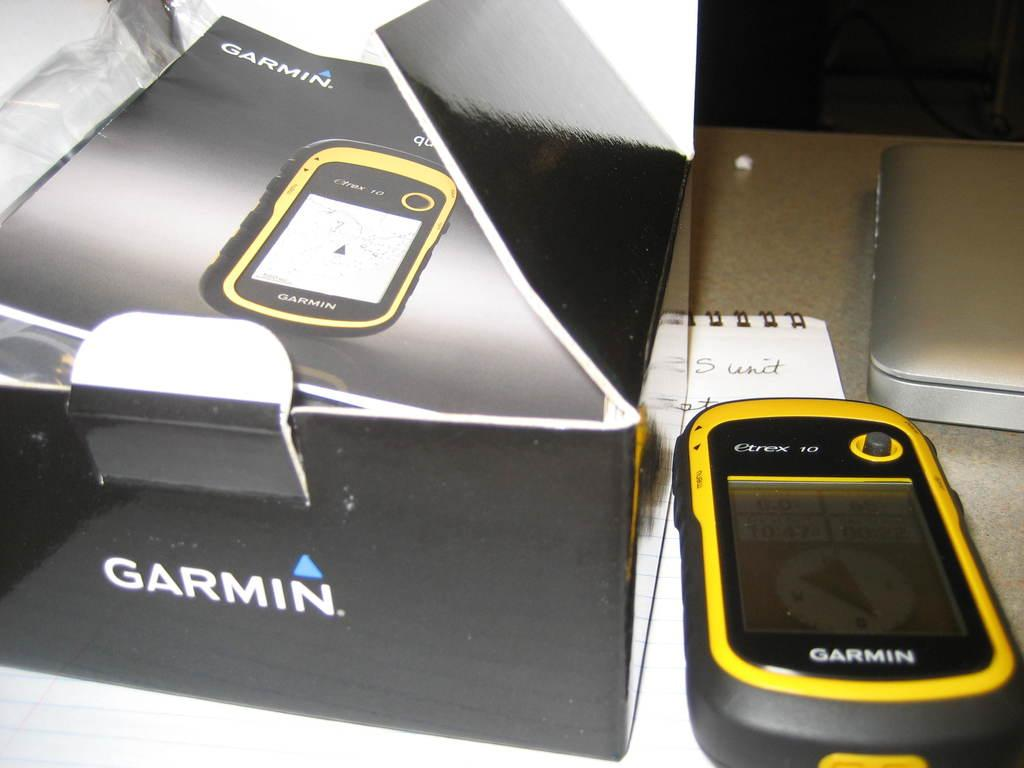<image>
Give a short and clear explanation of the subsequent image. the word garmin is on the black box 